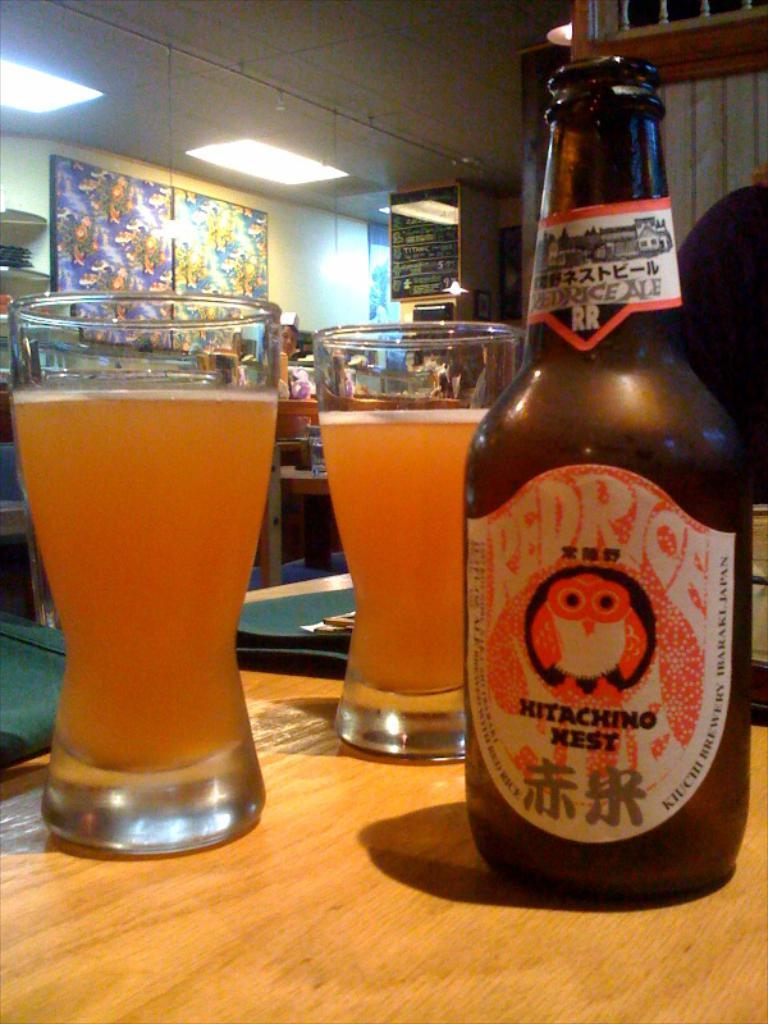<image>
Give a short and clear explanation of the subsequent image. A bottle of Redrice Hitaching Nest has been poured into two glasses. 